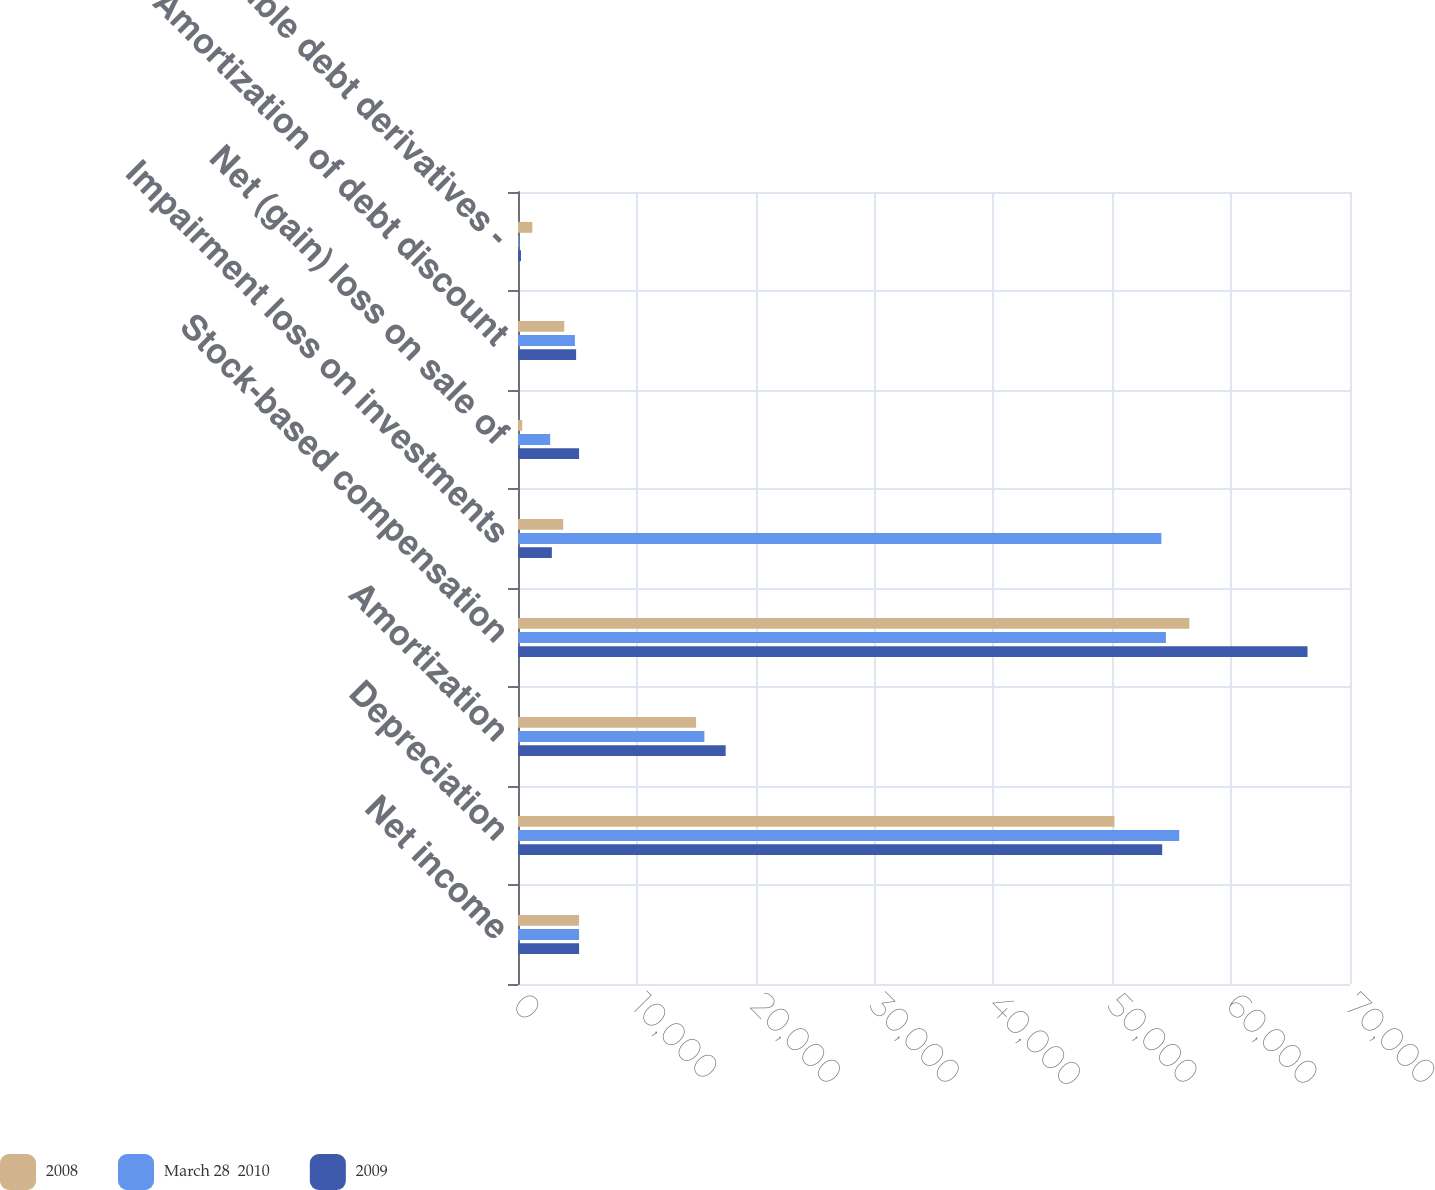<chart> <loc_0><loc_0><loc_500><loc_500><stacked_bar_chart><ecel><fcel>Net income<fcel>Depreciation<fcel>Amortization<fcel>Stock-based compensation<fcel>Impairment loss on investments<fcel>Net (gain) loss on sale of<fcel>Amortization of debt discount<fcel>Convertible debt derivatives -<nl><fcel>2008<fcel>5139<fcel>50180<fcel>14982<fcel>56481<fcel>3805<fcel>351<fcel>3892<fcel>1204<nl><fcel>March 28  2010<fcel>5139<fcel>55632<fcel>15682<fcel>54509<fcel>54129<fcel>2706<fcel>4789<fcel>97<nl><fcel>2009<fcel>5139<fcel>54199<fcel>17472<fcel>66427<fcel>2850<fcel>5139<fcel>4889<fcel>254<nl></chart> 